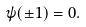Convert formula to latex. <formula><loc_0><loc_0><loc_500><loc_500>\psi ( \pm 1 ) = 0 .</formula> 